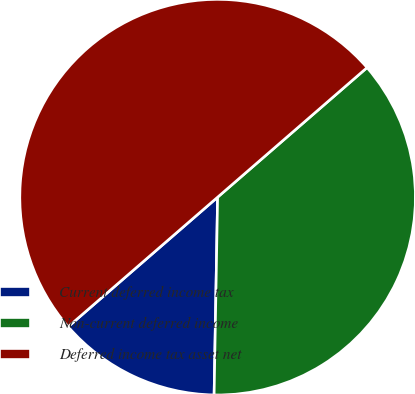Convert chart. <chart><loc_0><loc_0><loc_500><loc_500><pie_chart><fcel>Current deferred income tax<fcel>Non-current deferred income<fcel>Deferred income tax asset net<nl><fcel>13.35%<fcel>36.65%<fcel>50.0%<nl></chart> 